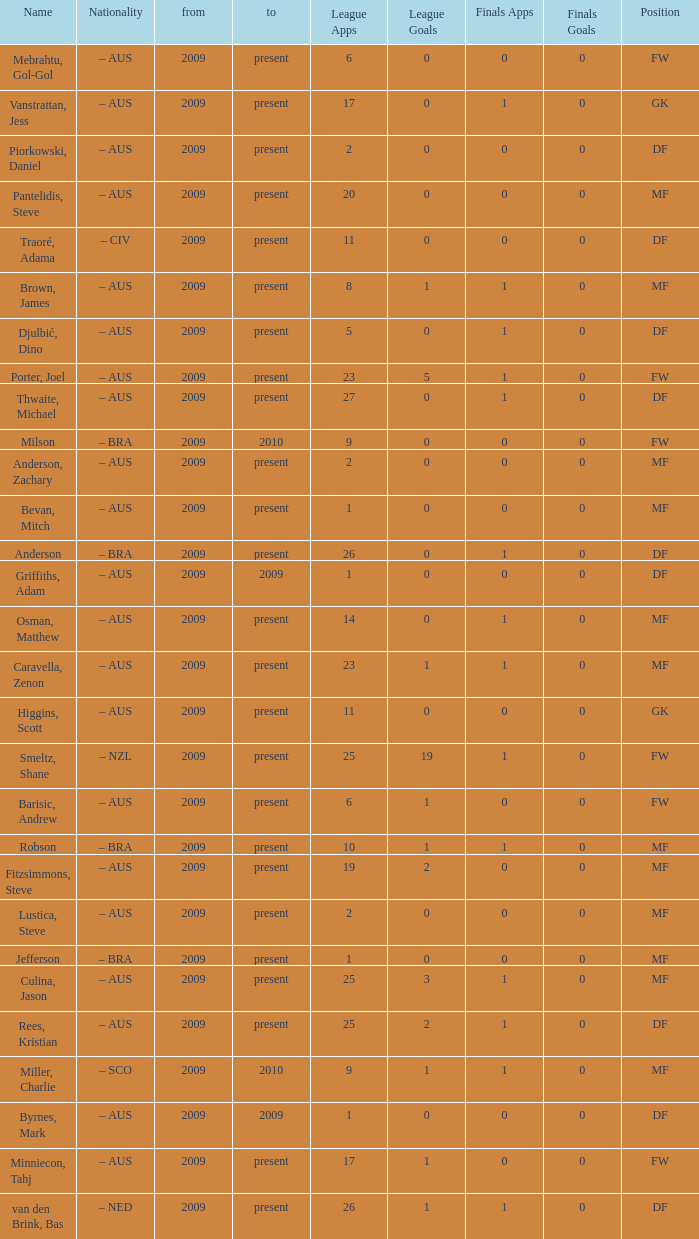Name the mosst finals apps 1.0. 